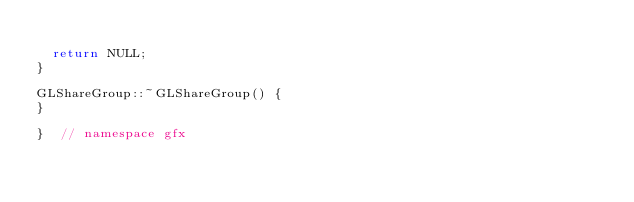<code> <loc_0><loc_0><loc_500><loc_500><_C++_>
  return NULL;
}

GLShareGroup::~GLShareGroup() {
}

}  // namespace gfx
</code> 